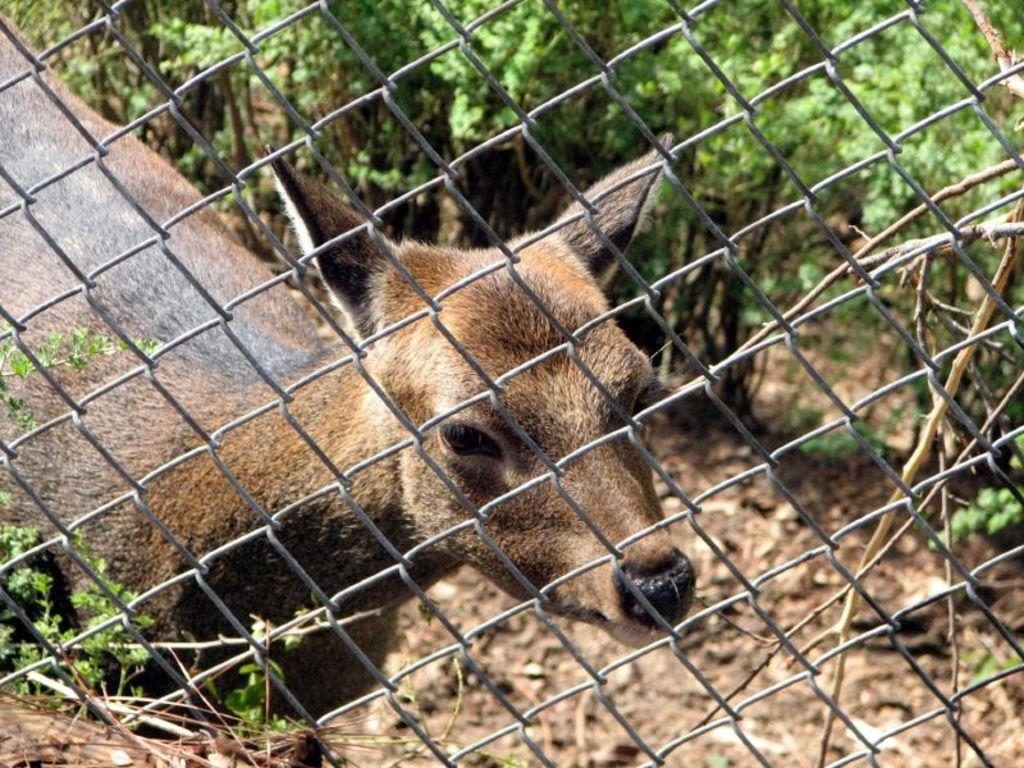What type of living creature is in the image? There is an animal in the image. What natural elements can be seen in the image? There are trees in the image. What man-made structure is present in the image? There is a fence in the image. What type of pin can be seen holding the border of the animal's clothing in the image? There is no pin or clothing present in the image; it features an animal, trees, and a fence. 